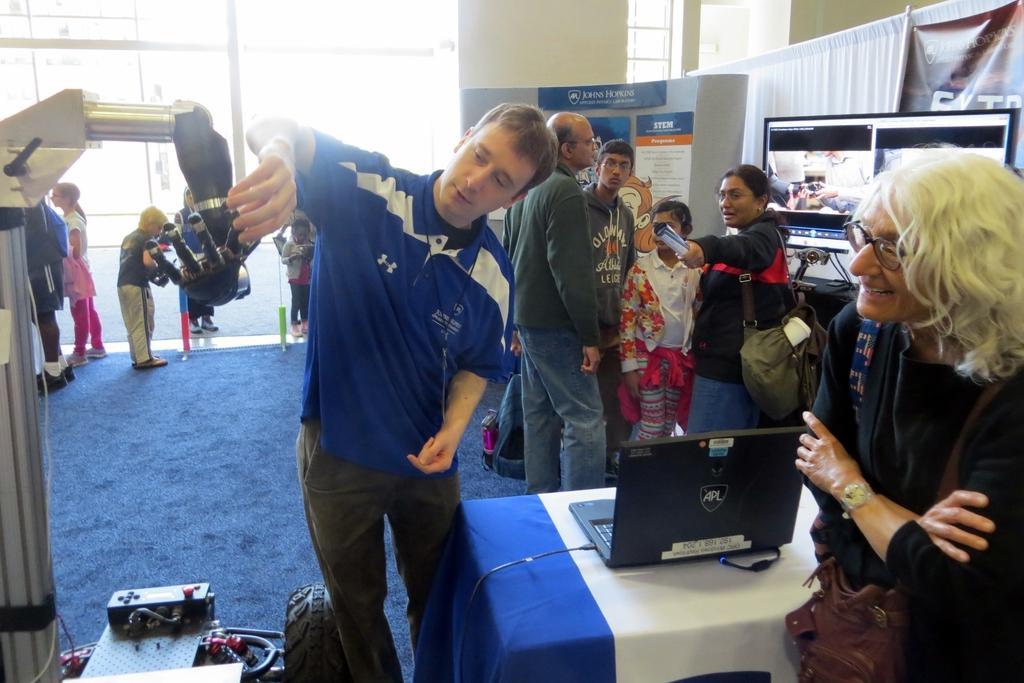How would you summarize this image in a sentence or two? In this image we can see a group of persons. In the foreground we can see a person holding the hand of a robot. Beside the person we can see a laptop on a table. In the bottom left there are few objects. On the right side, we can see a curtain and a screen. On the screen we can see some images. Behind the persons we can see a glass wall and posters with text. 